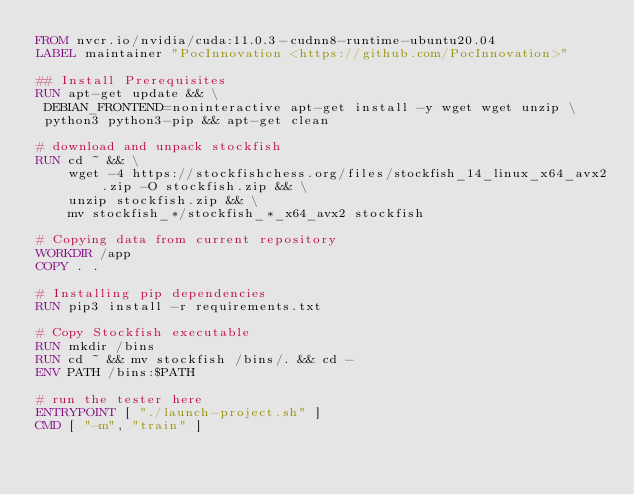<code> <loc_0><loc_0><loc_500><loc_500><_Dockerfile_>FROM nvcr.io/nvidia/cuda:11.0.3-cudnn8-runtime-ubuntu20.04
LABEL maintainer "PocInnovation <https://github.com/PocInnovation>"

## Install Prerequisites
RUN apt-get update && \
 DEBIAN_FRONTEND=noninteractive apt-get install -y wget wget unzip \
 python3 python3-pip && apt-get clean

# download and unpack stockfish
RUN cd ~ && \
    wget -4 https://stockfishchess.org/files/stockfish_14_linux_x64_avx2.zip -O stockfish.zip && \
    unzip stockfish.zip && \
    mv stockfish_*/stockfish_*_x64_avx2 stockfish

# Copying data from current repository
WORKDIR /app
COPY . .

# Installing pip dependencies
RUN pip3 install -r requirements.txt

# Copy Stockfish executable
RUN mkdir /bins
RUN cd ~ && mv stockfish /bins/. && cd -
ENV PATH /bins:$PATH

# run the tester here
ENTRYPOINT [ "./launch-project.sh" ]
CMD [ "-m", "train" ]
</code> 